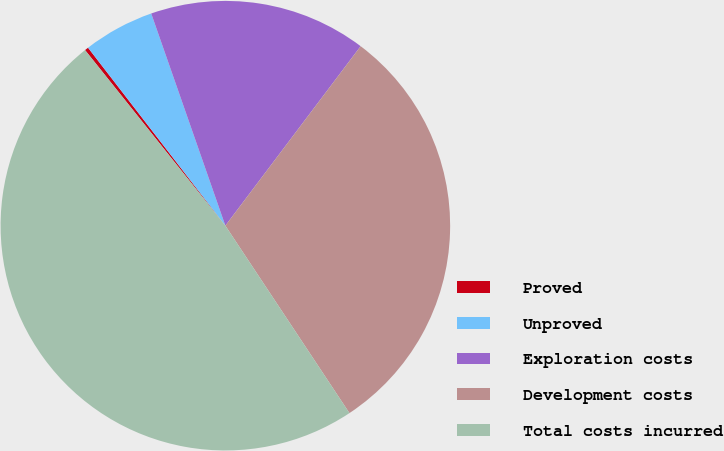Convert chart to OTSL. <chart><loc_0><loc_0><loc_500><loc_500><pie_chart><fcel>Proved<fcel>Unproved<fcel>Exploration costs<fcel>Development costs<fcel>Total costs incurred<nl><fcel>0.27%<fcel>5.11%<fcel>15.63%<fcel>30.41%<fcel>48.58%<nl></chart> 